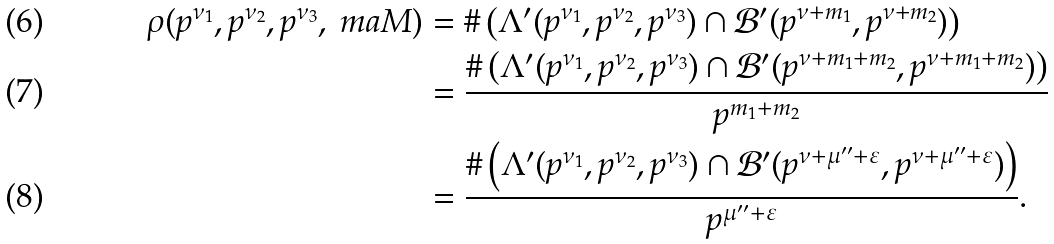Convert formula to latex. <formula><loc_0><loc_0><loc_500><loc_500>\rho ( p ^ { \nu _ { 1 } } , p ^ { \nu _ { 2 } } , p ^ { \nu _ { 3 } } , \ m a { M } ) & = \# \left ( \Lambda ^ { \prime } { ( p ^ { \nu _ { 1 } } , p ^ { \nu _ { 2 } } , p ^ { \nu _ { 3 } } ) } \cap \mathcal { B } ^ { \prime } ( p ^ { \nu + m _ { 1 } } , p ^ { \nu + m _ { 2 } } ) \right ) \\ & = \frac { \# \left ( \Lambda ^ { \prime } { ( p ^ { \nu _ { 1 } } , p ^ { \nu _ { 2 } } , p ^ { \nu _ { 3 } } ) } \cap \mathcal { B } ^ { \prime } ( p ^ { \nu + m _ { 1 } + m _ { 2 } } , p ^ { \nu + m _ { 1 } + m _ { 2 } } ) \right ) } { p ^ { m _ { 1 } + m _ { 2 } } } \\ & = \frac { \# \left ( \Lambda ^ { \prime } { ( p ^ { \nu _ { 1 } } , p ^ { \nu _ { 2 } } , p ^ { \nu _ { 3 } } ) } \cap \mathcal { B } ^ { \prime } ( p ^ { \nu + \mu ^ { \prime \prime } + \varepsilon } , p ^ { \nu + \mu ^ { \prime \prime } + \varepsilon } ) \right ) } { p ^ { \mu ^ { \prime \prime } + \varepsilon } } .</formula> 